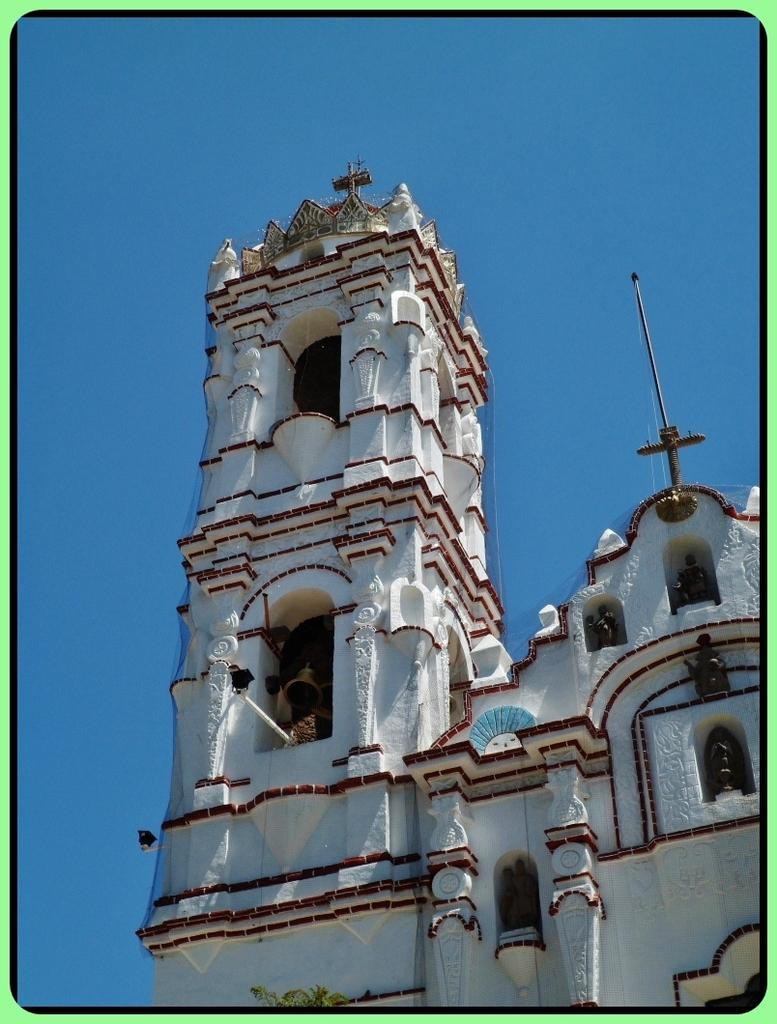What type of structure is present in the image? There is a building in the image. What object can be seen hanging from the building? There is a bell in the image. What religious symbol is present in the image? There is a cross in the image. What type of figures are present in the image? There are statues in the image. What can be seen in the background of the image? The sky is visible in the background of the image. What type of chess piece is located on the roof of the building in the image? There is no chess piece present on the roof of the building in the image. What type of cork can be seen in the image? There is no cork present in the image. 